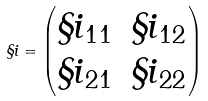Convert formula to latex. <formula><loc_0><loc_0><loc_500><loc_500>\S i = \begin{pmatrix} \S i _ { 1 1 } & \S i _ { 1 2 } \\ \S i _ { 2 1 } & \S i _ { 2 2 } \end{pmatrix}</formula> 